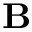<formula> <loc_0><loc_0><loc_500><loc_500>B</formula> 